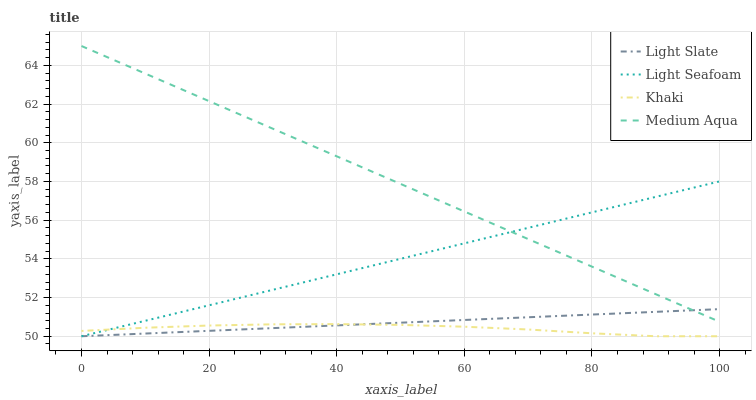Does Khaki have the minimum area under the curve?
Answer yes or no. Yes. Does Medium Aqua have the maximum area under the curve?
Answer yes or no. Yes. Does Light Seafoam have the minimum area under the curve?
Answer yes or no. No. Does Light Seafoam have the maximum area under the curve?
Answer yes or no. No. Is Light Slate the smoothest?
Answer yes or no. Yes. Is Khaki the roughest?
Answer yes or no. Yes. Is Medium Aqua the smoothest?
Answer yes or no. No. Is Medium Aqua the roughest?
Answer yes or no. No. Does Light Slate have the lowest value?
Answer yes or no. Yes. Does Medium Aqua have the lowest value?
Answer yes or no. No. Does Medium Aqua have the highest value?
Answer yes or no. Yes. Does Light Seafoam have the highest value?
Answer yes or no. No. Is Khaki less than Medium Aqua?
Answer yes or no. Yes. Is Medium Aqua greater than Khaki?
Answer yes or no. Yes. Does Light Slate intersect Light Seafoam?
Answer yes or no. Yes. Is Light Slate less than Light Seafoam?
Answer yes or no. No. Is Light Slate greater than Light Seafoam?
Answer yes or no. No. Does Khaki intersect Medium Aqua?
Answer yes or no. No. 